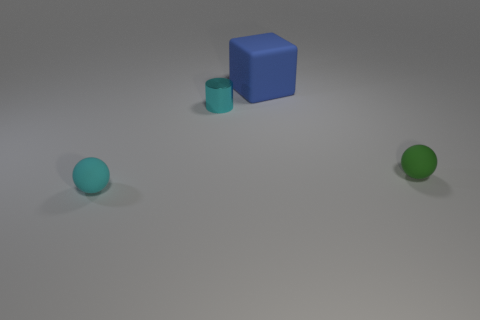How many other objects are there of the same material as the tiny cyan cylinder?
Keep it short and to the point. 0. Do the big object and the tiny sphere that is to the right of the large object have the same material?
Give a very brief answer. Yes. The matte ball to the right of the matte object that is on the left side of the shiny cylinder left of the large blue matte cube is what color?
Your response must be concise. Green. The cyan object that is the same size as the cyan shiny cylinder is what shape?
Your answer should be compact. Sphere. Is there any other thing that has the same size as the cyan metal cylinder?
Your answer should be compact. Yes. There is a sphere that is on the left side of the tiny shiny cylinder; is its size the same as the sphere that is on the right side of the big rubber object?
Make the answer very short. Yes. There is a sphere behind the cyan matte sphere; how big is it?
Provide a succinct answer. Small. There is a ball that is the same color as the metal cylinder; what material is it?
Your answer should be compact. Rubber. There is a metal object that is the same size as the green matte ball; what color is it?
Offer a very short reply. Cyan. Do the green sphere and the cyan matte thing have the same size?
Give a very brief answer. Yes. 